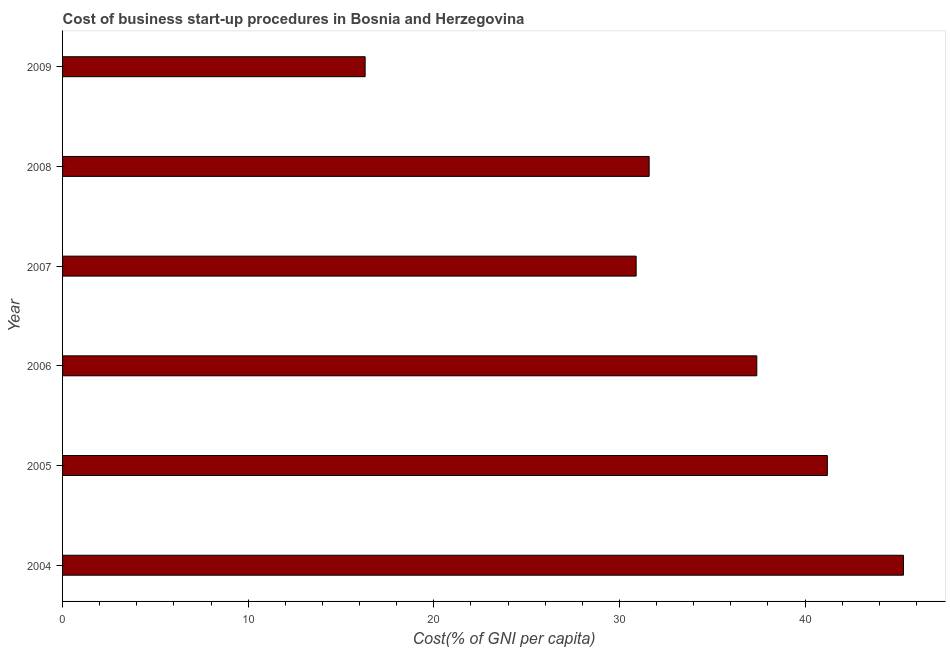What is the title of the graph?
Your response must be concise. Cost of business start-up procedures in Bosnia and Herzegovina. What is the label or title of the X-axis?
Provide a succinct answer. Cost(% of GNI per capita). What is the label or title of the Y-axis?
Ensure brevity in your answer.  Year. What is the cost of business startup procedures in 2007?
Ensure brevity in your answer.  30.9. Across all years, what is the maximum cost of business startup procedures?
Offer a very short reply. 45.3. In which year was the cost of business startup procedures maximum?
Ensure brevity in your answer.  2004. In which year was the cost of business startup procedures minimum?
Provide a succinct answer. 2009. What is the sum of the cost of business startup procedures?
Keep it short and to the point. 202.7. What is the average cost of business startup procedures per year?
Keep it short and to the point. 33.78. What is the median cost of business startup procedures?
Ensure brevity in your answer.  34.5. Do a majority of the years between 2008 and 2009 (inclusive) have cost of business startup procedures greater than 34 %?
Offer a terse response. No. What is the ratio of the cost of business startup procedures in 2007 to that in 2009?
Provide a short and direct response. 1.9. What is the difference between the highest and the second highest cost of business startup procedures?
Offer a very short reply. 4.1. Is the sum of the cost of business startup procedures in 2006 and 2009 greater than the maximum cost of business startup procedures across all years?
Keep it short and to the point. Yes. How many years are there in the graph?
Your answer should be compact. 6. What is the Cost(% of GNI per capita) in 2004?
Your response must be concise. 45.3. What is the Cost(% of GNI per capita) in 2005?
Your answer should be compact. 41.2. What is the Cost(% of GNI per capita) in 2006?
Provide a succinct answer. 37.4. What is the Cost(% of GNI per capita) of 2007?
Offer a terse response. 30.9. What is the Cost(% of GNI per capita) in 2008?
Provide a succinct answer. 31.6. What is the Cost(% of GNI per capita) of 2009?
Ensure brevity in your answer.  16.3. What is the difference between the Cost(% of GNI per capita) in 2004 and 2005?
Your answer should be compact. 4.1. What is the difference between the Cost(% of GNI per capita) in 2004 and 2006?
Offer a terse response. 7.9. What is the difference between the Cost(% of GNI per capita) in 2004 and 2007?
Ensure brevity in your answer.  14.4. What is the difference between the Cost(% of GNI per capita) in 2005 and 2006?
Provide a short and direct response. 3.8. What is the difference between the Cost(% of GNI per capita) in 2005 and 2008?
Your response must be concise. 9.6. What is the difference between the Cost(% of GNI per capita) in 2005 and 2009?
Your response must be concise. 24.9. What is the difference between the Cost(% of GNI per capita) in 2006 and 2009?
Your answer should be compact. 21.1. What is the difference between the Cost(% of GNI per capita) in 2007 and 2008?
Your response must be concise. -0.7. What is the difference between the Cost(% of GNI per capita) in 2008 and 2009?
Give a very brief answer. 15.3. What is the ratio of the Cost(% of GNI per capita) in 2004 to that in 2006?
Give a very brief answer. 1.21. What is the ratio of the Cost(% of GNI per capita) in 2004 to that in 2007?
Give a very brief answer. 1.47. What is the ratio of the Cost(% of GNI per capita) in 2004 to that in 2008?
Your answer should be compact. 1.43. What is the ratio of the Cost(% of GNI per capita) in 2004 to that in 2009?
Give a very brief answer. 2.78. What is the ratio of the Cost(% of GNI per capita) in 2005 to that in 2006?
Ensure brevity in your answer.  1.1. What is the ratio of the Cost(% of GNI per capita) in 2005 to that in 2007?
Make the answer very short. 1.33. What is the ratio of the Cost(% of GNI per capita) in 2005 to that in 2008?
Your answer should be very brief. 1.3. What is the ratio of the Cost(% of GNI per capita) in 2005 to that in 2009?
Provide a short and direct response. 2.53. What is the ratio of the Cost(% of GNI per capita) in 2006 to that in 2007?
Offer a very short reply. 1.21. What is the ratio of the Cost(% of GNI per capita) in 2006 to that in 2008?
Ensure brevity in your answer.  1.18. What is the ratio of the Cost(% of GNI per capita) in 2006 to that in 2009?
Make the answer very short. 2.29. What is the ratio of the Cost(% of GNI per capita) in 2007 to that in 2009?
Ensure brevity in your answer.  1.9. What is the ratio of the Cost(% of GNI per capita) in 2008 to that in 2009?
Provide a short and direct response. 1.94. 